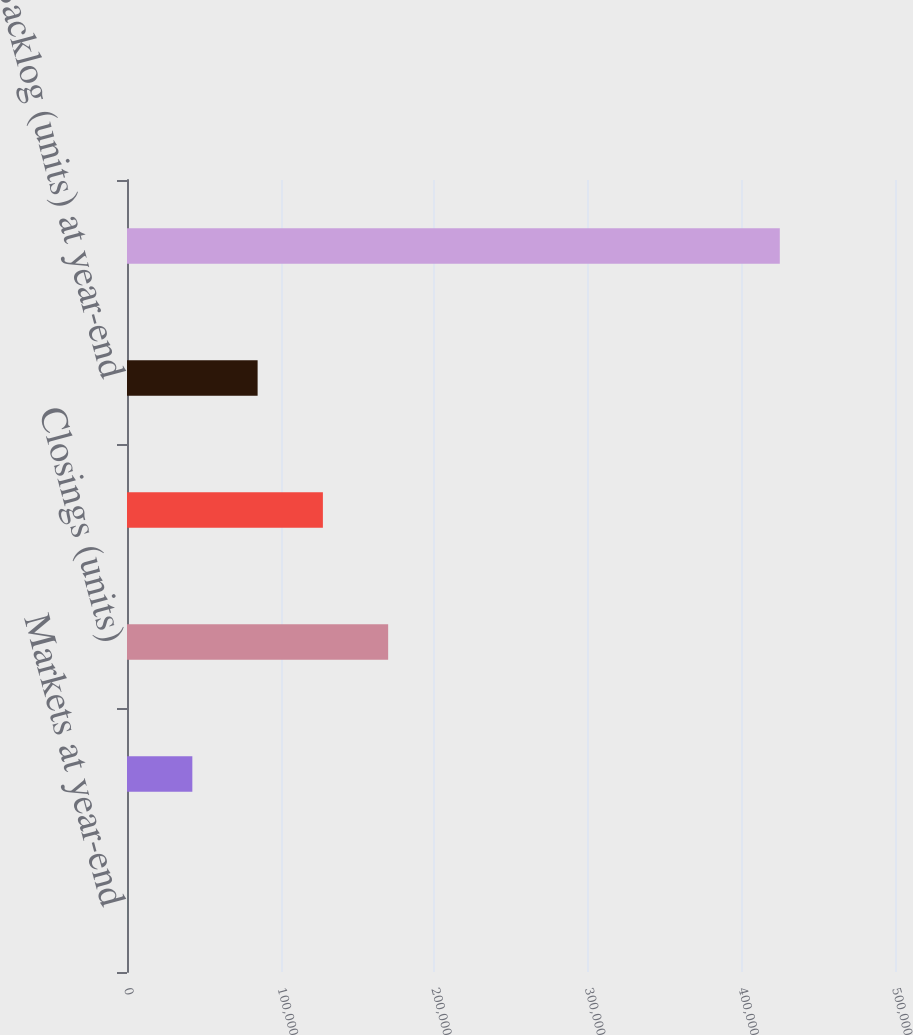Convert chart to OTSL. <chart><loc_0><loc_0><loc_500><loc_500><bar_chart><fcel>Markets at year-end<fcel>Active communities at year-end<fcel>Closings (units)<fcel>Net new orders (units)<fcel>Backlog (units) at year-end<fcel>Average selling price (per<nl><fcel>44<fcel>42539.6<fcel>170026<fcel>127531<fcel>85035.2<fcel>425000<nl></chart> 